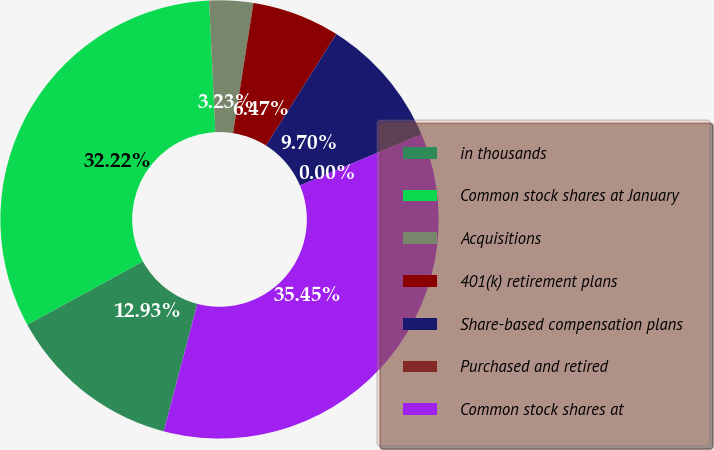Convert chart to OTSL. <chart><loc_0><loc_0><loc_500><loc_500><pie_chart><fcel>in thousands<fcel>Common stock shares at January<fcel>Acquisitions<fcel>401(k) retirement plans<fcel>Share-based compensation plans<fcel>Purchased and retired<fcel>Common stock shares at<nl><fcel>12.93%<fcel>32.22%<fcel>3.23%<fcel>6.47%<fcel>9.7%<fcel>0.0%<fcel>35.45%<nl></chart> 